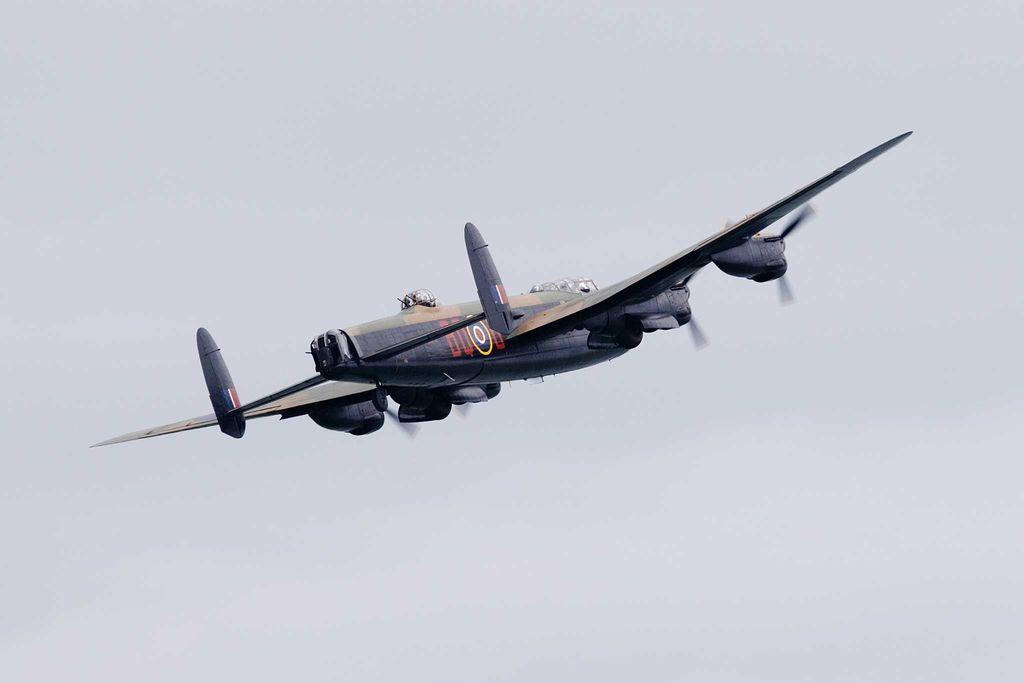What is the main subject of the image? The main subject of the image is an aircraft. Where is the aircraft located in the image? The aircraft is in the air in the image. What can be seen on the aircraft? There is text or writing on the aircraft. What is visible in the background of the image? The sky is visible in the background of the image. What type of faucet can be seen on the aircraft in the image? There is no faucet present on the aircraft in the image. Can you describe the texture of the clouds in the image? The image does not show any clouds, only the sky is visible in the background. 